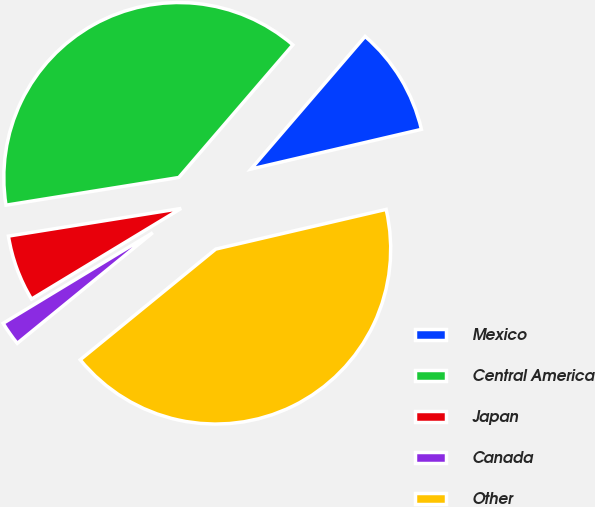<chart> <loc_0><loc_0><loc_500><loc_500><pie_chart><fcel>Mexico<fcel>Central America<fcel>Japan<fcel>Canada<fcel>Other<nl><fcel>10.05%<fcel>38.83%<fcel>6.14%<fcel>2.23%<fcel>42.74%<nl></chart> 